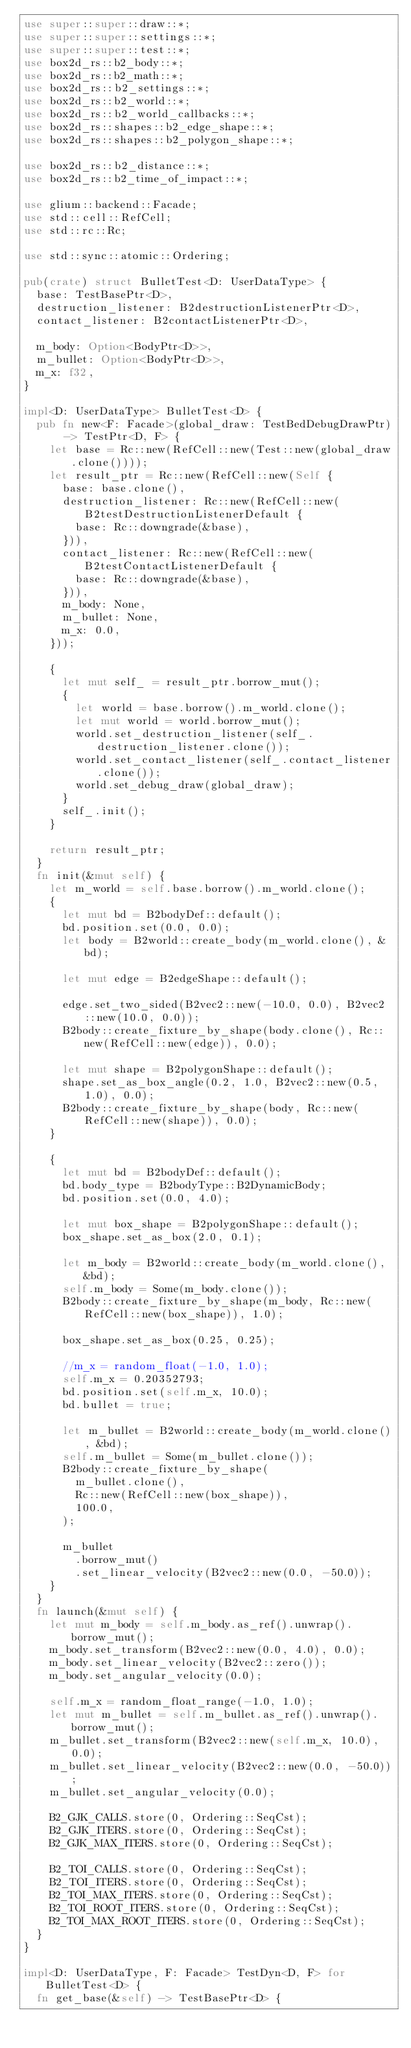<code> <loc_0><loc_0><loc_500><loc_500><_Rust_>use super::super::draw::*;
use super::super::settings::*;
use super::super::test::*;
use box2d_rs::b2_body::*;
use box2d_rs::b2_math::*;
use box2d_rs::b2_settings::*;
use box2d_rs::b2_world::*;
use box2d_rs::b2_world_callbacks::*;
use box2d_rs::shapes::b2_edge_shape::*;
use box2d_rs::shapes::b2_polygon_shape::*;

use box2d_rs::b2_distance::*;
use box2d_rs::b2_time_of_impact::*;

use glium::backend::Facade;
use std::cell::RefCell;
use std::rc::Rc;

use std::sync::atomic::Ordering;

pub(crate) struct BulletTest<D: UserDataType> {
	base: TestBasePtr<D>,
	destruction_listener: B2destructionListenerPtr<D>,
	contact_listener: B2contactListenerPtr<D>,

	m_body: Option<BodyPtr<D>>,
	m_bullet: Option<BodyPtr<D>>,
	m_x: f32,
}

impl<D: UserDataType> BulletTest<D> {
	pub fn new<F: Facade>(global_draw: TestBedDebugDrawPtr) -> TestPtr<D, F> {
		let base = Rc::new(RefCell::new(Test::new(global_draw.clone())));
		let result_ptr = Rc::new(RefCell::new(Self {
			base: base.clone(),
			destruction_listener: Rc::new(RefCell::new(B2testDestructionListenerDefault {
				base: Rc::downgrade(&base),
			})),
			contact_listener: Rc::new(RefCell::new(B2testContactListenerDefault {
				base: Rc::downgrade(&base),
			})),
			m_body: None,
			m_bullet: None,
			m_x: 0.0,
		}));

		{
			let mut self_ = result_ptr.borrow_mut();
			{
				let world = base.borrow().m_world.clone();
				let mut world = world.borrow_mut();
				world.set_destruction_listener(self_.destruction_listener.clone());
				world.set_contact_listener(self_.contact_listener.clone());
				world.set_debug_draw(global_draw);
			}
			self_.init();
		}

		return result_ptr;
	}
	fn init(&mut self) {
		let m_world = self.base.borrow().m_world.clone();
		{
			let mut bd = B2bodyDef::default();
			bd.position.set(0.0, 0.0);
			let body = B2world::create_body(m_world.clone(), &bd);

			let mut edge = B2edgeShape::default();

			edge.set_two_sided(B2vec2::new(-10.0, 0.0), B2vec2::new(10.0, 0.0));
			B2body::create_fixture_by_shape(body.clone(), Rc::new(RefCell::new(edge)), 0.0);

			let mut shape = B2polygonShape::default();
			shape.set_as_box_angle(0.2, 1.0, B2vec2::new(0.5, 1.0), 0.0);
			B2body::create_fixture_by_shape(body, Rc::new(RefCell::new(shape)), 0.0);
		}

		{
			let mut bd = B2bodyDef::default();
			bd.body_type = B2bodyType::B2DynamicBody;
			bd.position.set(0.0, 4.0);

			let mut box_shape = B2polygonShape::default();
			box_shape.set_as_box(2.0, 0.1);

			let m_body = B2world::create_body(m_world.clone(), &bd);
			self.m_body = Some(m_body.clone());
			B2body::create_fixture_by_shape(m_body, Rc::new(RefCell::new(box_shape)), 1.0);

			box_shape.set_as_box(0.25, 0.25);

			//m_x = random_float(-1.0, 1.0);
			self.m_x = 0.20352793;
			bd.position.set(self.m_x, 10.0);
			bd.bullet = true;

			let m_bullet = B2world::create_body(m_world.clone(), &bd);
			self.m_bullet = Some(m_bullet.clone());
			B2body::create_fixture_by_shape(
				m_bullet.clone(),
				Rc::new(RefCell::new(box_shape)),
				100.0,
			);

			m_bullet
				.borrow_mut()
				.set_linear_velocity(B2vec2::new(0.0, -50.0));
		}
	}
	fn launch(&mut self) {
		let mut m_body = self.m_body.as_ref().unwrap().borrow_mut();
		m_body.set_transform(B2vec2::new(0.0, 4.0), 0.0);
		m_body.set_linear_velocity(B2vec2::zero());
		m_body.set_angular_velocity(0.0);

		self.m_x = random_float_range(-1.0, 1.0);
		let mut m_bullet = self.m_bullet.as_ref().unwrap().borrow_mut();
		m_bullet.set_transform(B2vec2::new(self.m_x, 10.0), 0.0);
		m_bullet.set_linear_velocity(B2vec2::new(0.0, -50.0));
		m_bullet.set_angular_velocity(0.0);

		B2_GJK_CALLS.store(0, Ordering::SeqCst);
		B2_GJK_ITERS.store(0, Ordering::SeqCst);
		B2_GJK_MAX_ITERS.store(0, Ordering::SeqCst);

		B2_TOI_CALLS.store(0, Ordering::SeqCst);
		B2_TOI_ITERS.store(0, Ordering::SeqCst);
		B2_TOI_MAX_ITERS.store(0, Ordering::SeqCst);
		B2_TOI_ROOT_ITERS.store(0, Ordering::SeqCst);
		B2_TOI_MAX_ROOT_ITERS.store(0, Ordering::SeqCst);
	}
}

impl<D: UserDataType, F: Facade> TestDyn<D, F> for BulletTest<D> {
	fn get_base(&self) -> TestBasePtr<D> {</code> 